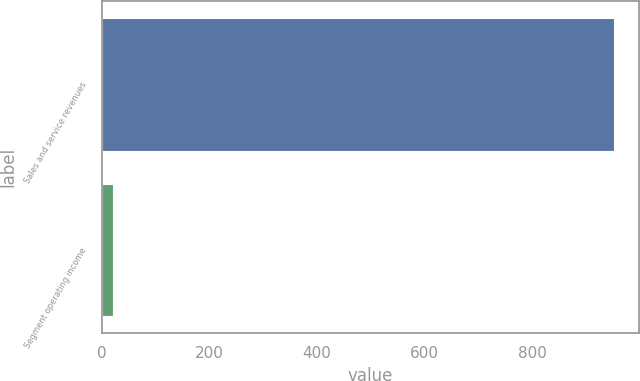<chart> <loc_0><loc_0><loc_500><loc_500><bar_chart><fcel>Sales and service revenues<fcel>Segment operating income<nl><fcel>952<fcel>21<nl></chart> 